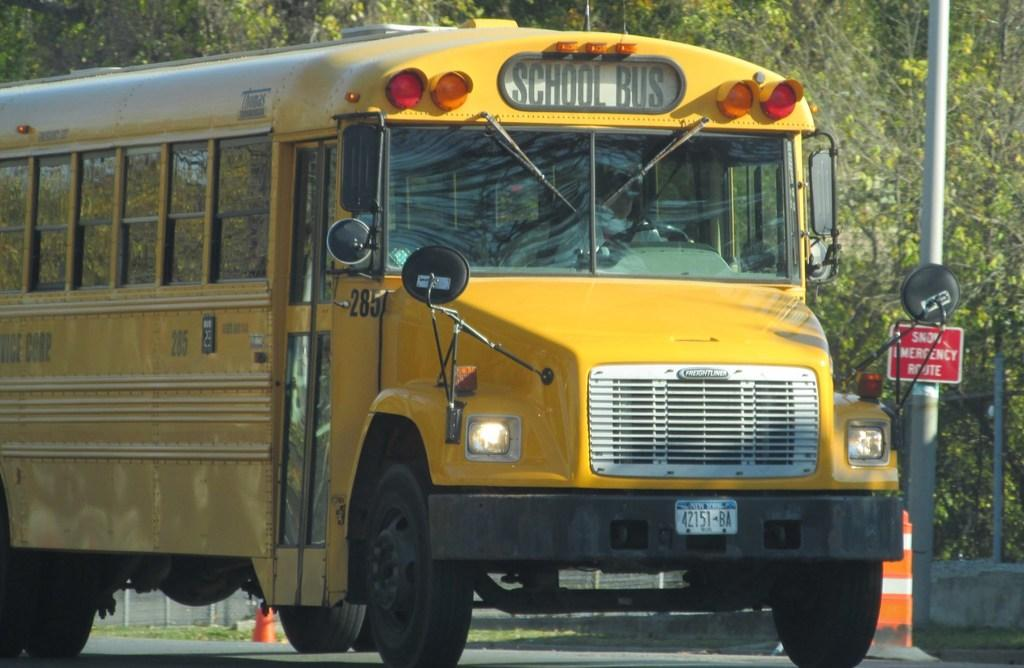<image>
Provide a brief description of the given image. The yellow school bus has the number 285 written on it. 